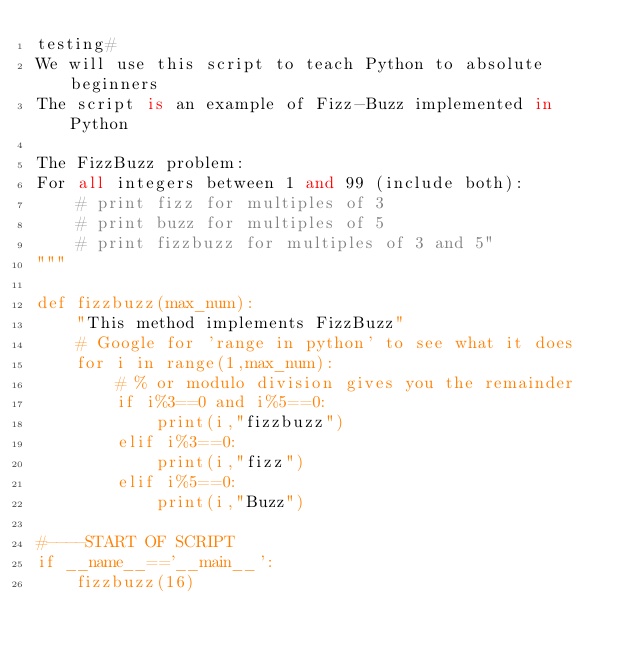Convert code to text. <code><loc_0><loc_0><loc_500><loc_500><_Python_>testing#
We will use this script to teach Python to absolute beginners
The script is an example of Fizz-Buzz implemented in Python

The FizzBuzz problem: 
For all integers between 1 and 99 (include both):
    # print fizz for multiples of 3
    # print buzz for multiples of 5 
    # print fizzbuzz for multiples of 3 and 5"
"""

def fizzbuzz(max_num):
    "This method implements FizzBuzz"
    # Google for 'range in python' to see what it does
    for i in range(1,max_num):
        # % or modulo division gives you the remainder 
        if i%3==0 and i%5==0:
            print(i,"fizzbuzz")
        elif i%3==0:
            print(i,"fizz")
        elif i%5==0:
            print(i,"Buzz")

#----START OF SCRIPT
if __name__=='__main__':
    fizzbuzz(16)
</code> 